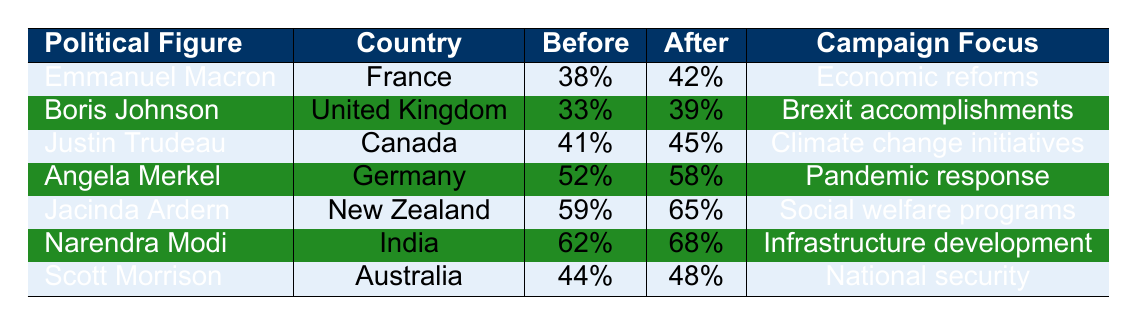What was Emmanuel Macron's public approval rating before the campaign? The table indicates that Emmanuel Macron had an approval rating of 38% before the campaign began.
Answer: 38% Which political figure saw the highest increase in approval rating after their campaign? By examining the difference between the before and after ratings, Jacinda Ardern's approval rose from 59% to 65%, a 6% increase, which is the highest growth among the listed figures.
Answer: Jacinda Ardern Is it true that Boris Johnson's approval rating increased after the media campaign? Yes, the table shows that Boris Johnson's approval rating increased from 33% to 39%, confirming a positive change after the campaign.
Answer: Yes What is the average approval rating increase across all political figures after their campaigns? To find the average increase, calculate the increases for each political figure: Macron (4), Johnson (6), Trudeau (4), Merkel (6), Ardern (6), Modi (6), Morrison (4). The total increase is 36, divided by 7 (the number of figures) equals approximately 5.14.
Answer: Approximately 5.14% Which country had the highest approval rating after the campaign? Looking at the table, Narendra Modi from India had the highest approval rating after the campaign at 68%.
Answer: India Was the approval rating of Scott Morrison above 45% after the campaign? The table lists Scott Morrison's after-campaign approval rating as 48%, which is indeed above 45%.
Answer: Yes What is the median public approval rating before the campaigns started? First, list the before-campaign ratings: 38, 33, 41, 52, 59, 62, 44. Organizing these gives: 33, 38, 41, 44, 52, 59, 62. The median, being the middle value, is 44.
Answer: 44 